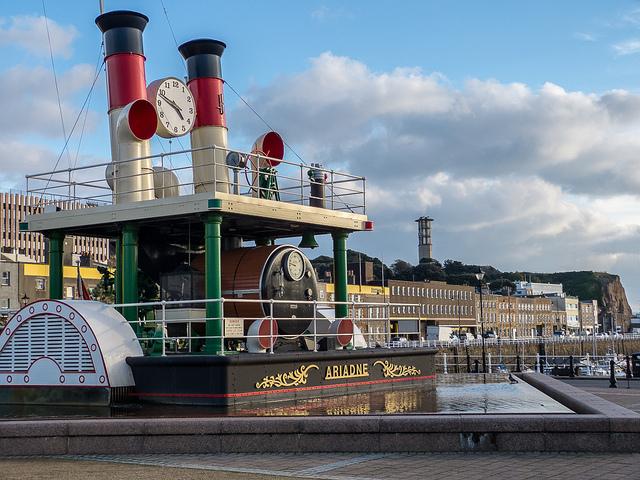What is the large metal object on the back of the boat?
Be succinct. Fan. What time is it?
Give a very brief answer. 4:50. What is the red pole?
Short answer required. Steam pipe. Is this a dock?
Keep it brief. Yes. 